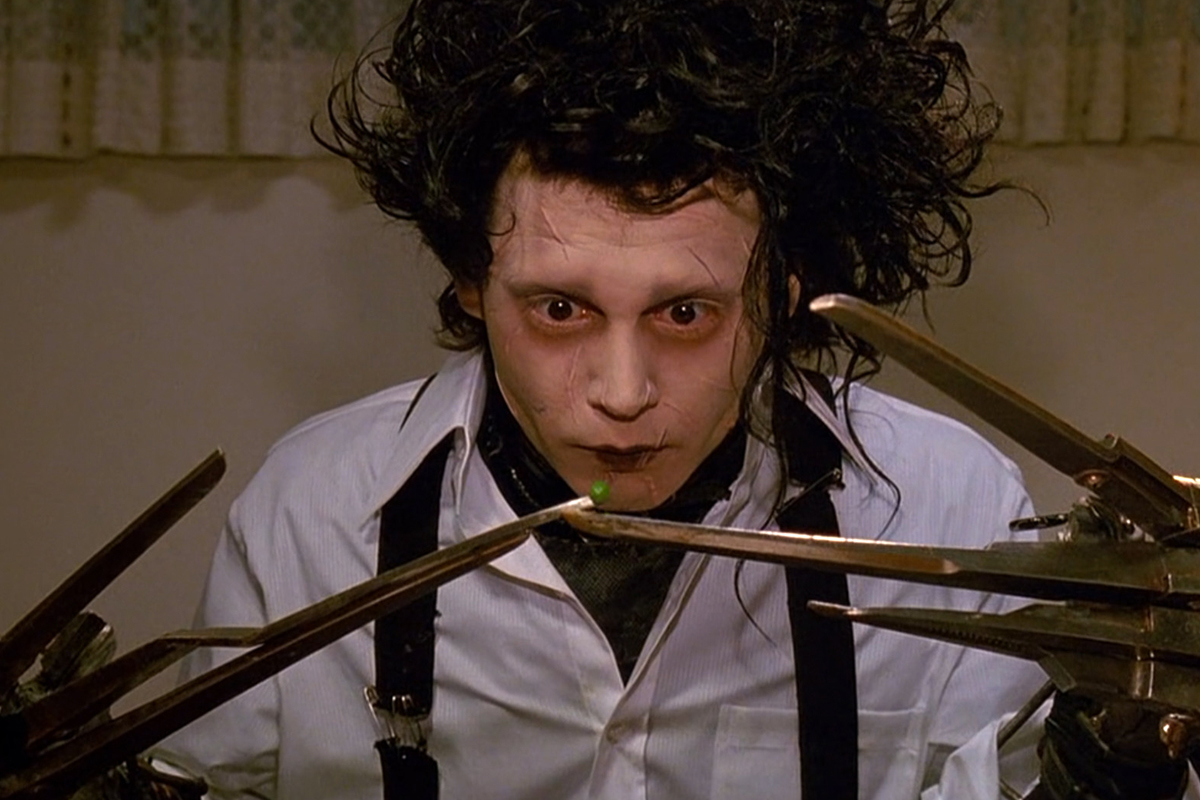What emotion do you think Edward is experiencing in this scene? In this scene, Edward seems to be experiencing a mixture of curiosity and melancholy. His wide-eyed, intense focus on the delicate task of handling the pea with his scissor hands reflects his perpetual struggle with the simple, everyday actions that most people take for granted. The overall expression on his face, combined with his sad and tentative demeanor, suggests a deep sense of isolation and longing. How does the use of color in this image contribute to the mood? The use of color in this image significantly contributes to the overall mood. Edward's pale complexion and the dark circles around his eyes create a ghostly, otherworldly aura, highlighting his difference from those around him. His white shirt and black tie add stark, contrasting elements that emphasize his somber and solemn demeanor. The dull, muted tones of the background, including the curtains, serve to keep the focus on Edward, amplifying the sense of isolation and emphasizing his plight. The single green pea stands out as a symbol of his delicate interaction with the world. 